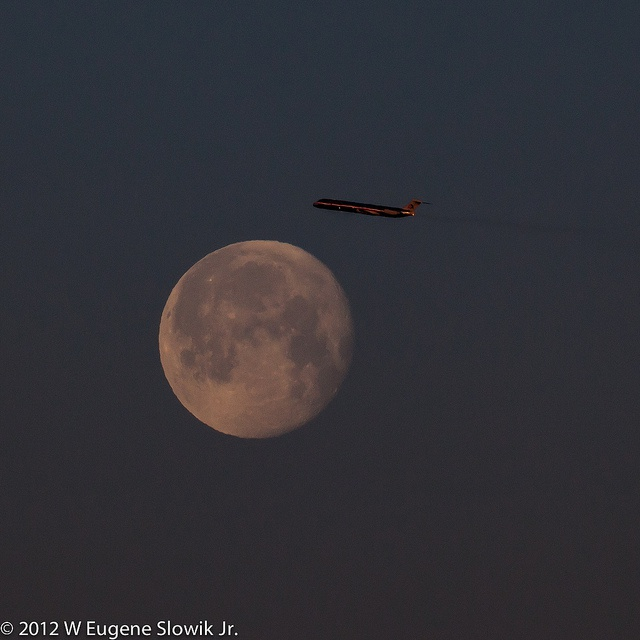Describe the objects in this image and their specific colors. I can see a airplane in black, maroon, and brown tones in this image. 